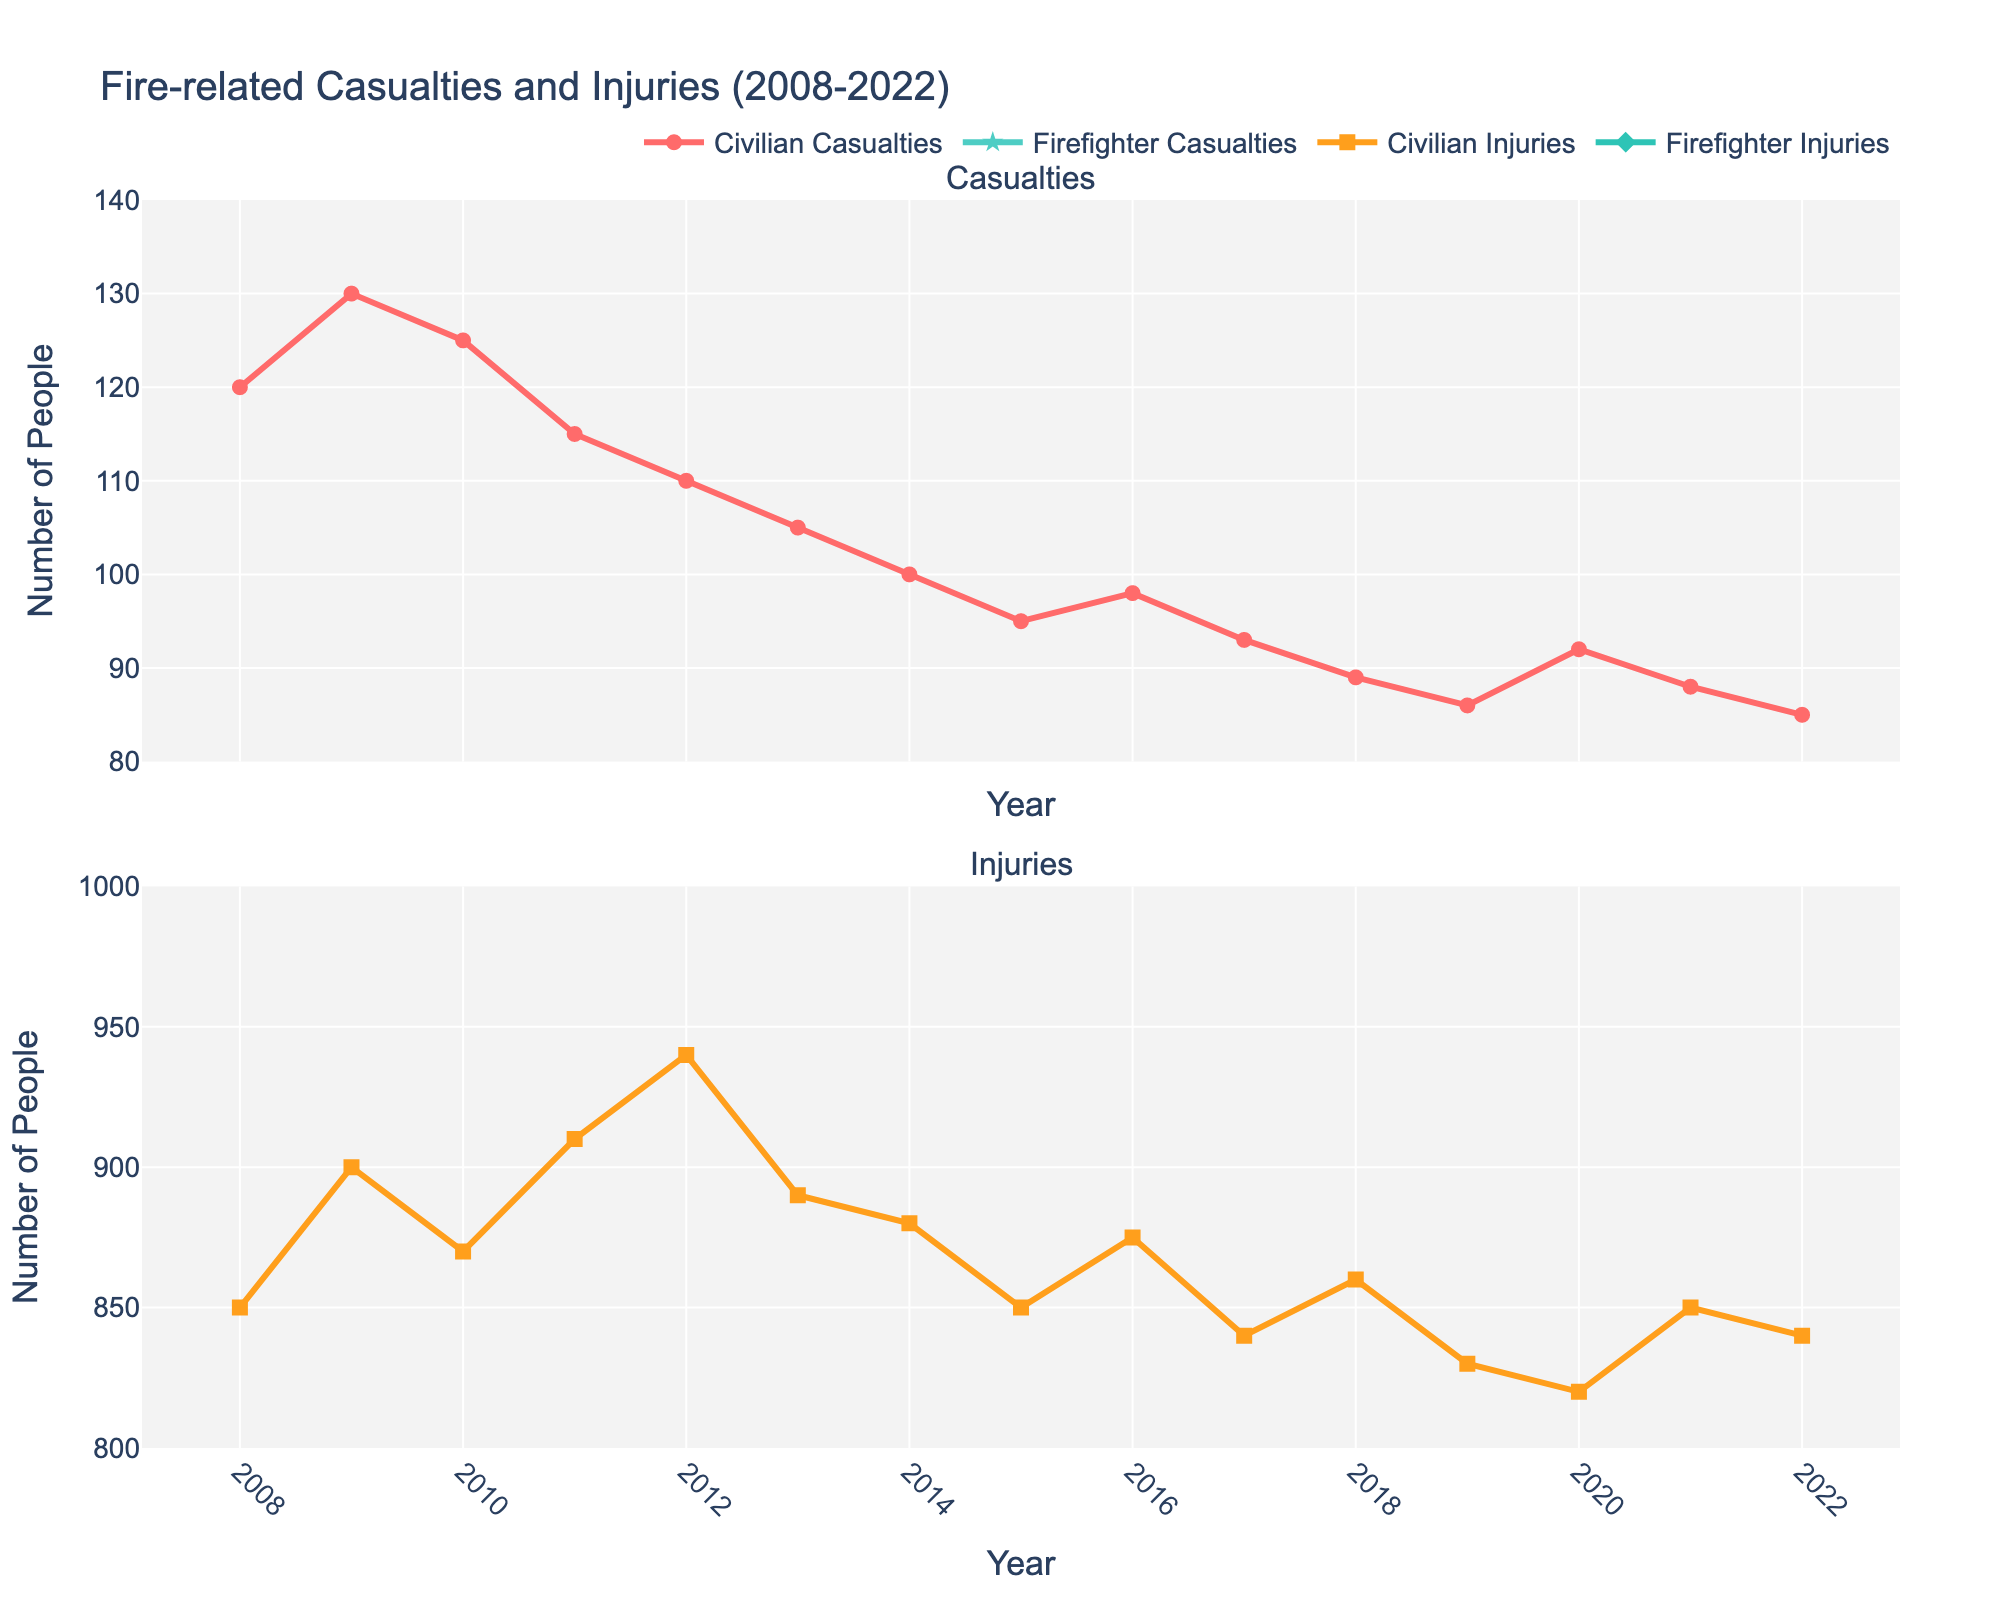What is the title of the figure? The title is located at the top of the plot and it usually describes the overall theme of the graph.
Answer: Fire-related Casualties and Injuries (2008-2022) How many subplots are there in the figure? The figure has been divided horizontally into separate sections; these are the subplots.
Answer: 2 What color is used to represent Civilian Casualties? Civilian Casualties are represented by a specific color line and markers in the plot.
Answer: Red What was the peak year for Civilian Injuries according to the figure? Look at the line representing Civilian Injuries and find the highest point on the graph to determine the peak year.
Answer: 2012 How many Civilian Casualties were reported in 2020? Locate the year 2020 on the x-axis, then check where the Civilian Casualties line intersects to find the value.
Answer: 92 What is the range of years represented in this figure? Identify the starting and ending years shown on the x-axis to find the range.
Answer: 2008-2022 Has there been an increase or decrease in Firefighter Injuries from 2008 to 2022? Examine the trend in the line representing Firefighter Injuries from 2008 to 2022.
Answer: Increase Which year saw the highest number of Firefighter Injuries, and what was the number? Find the highest peak in the Firefighter Injuries plot and note the corresponding year and value.
Answer: 2021, 180 Compare the number of Civilian Casualties and Firefighter Casualties in 2011. Which one is higher and by how much? Locate the 2011 data points for both Civilian and Firefighter Casualties and calculate the difference.
Answer: Civilian Casualties are higher by 110 What is the average number of Civilian Casualties over the 15-year period? Sum the number of Civilian Casualties from each year and divide by the number of years.
Answer: (120 + 130 + 125 + 115 + 110 + 105 + 100 + 95 + 98 + 93 + 89 + 86 + 92 + 88 + 85) / 15 = 102.6 